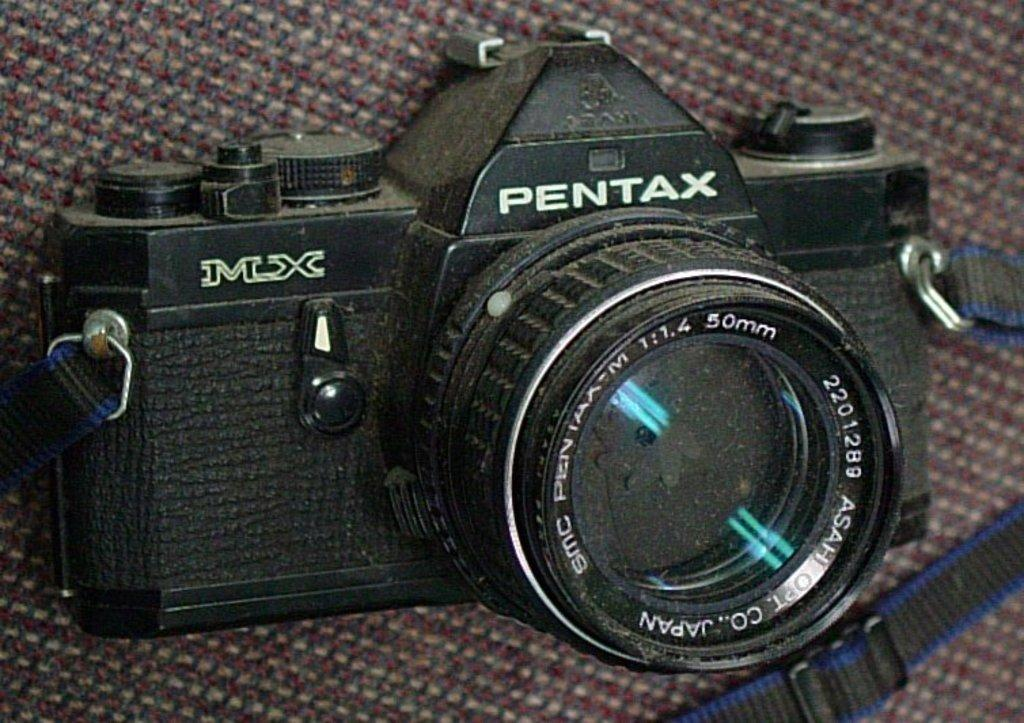What is the main object in the image? There is a camera in the image. What can be seen on the camera besides its body? There is text and numbers on the camera. How might the camera be carried or held? There is a strap on the camera for carrying or holding it. What type of activity are the frogs participating in near the camera in the image? There are no frogs present in the image, so it is not possible to answer that question. 